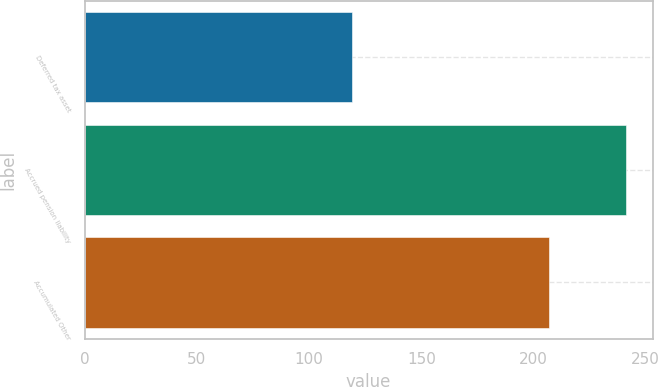<chart> <loc_0><loc_0><loc_500><loc_500><bar_chart><fcel>Deferred tax asset<fcel>Accrued pension liability<fcel>Accumulated Other<nl><fcel>119<fcel>241<fcel>207<nl></chart> 